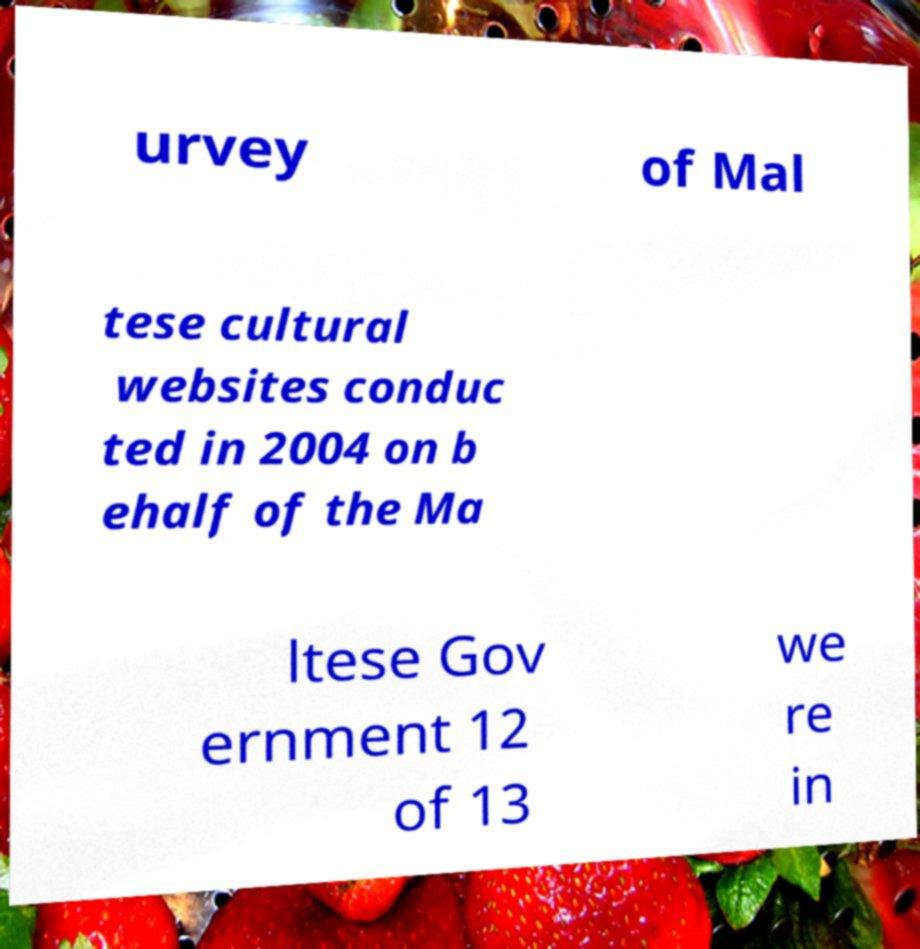Can you read and provide the text displayed in the image?This photo seems to have some interesting text. Can you extract and type it out for me? urvey of Mal tese cultural websites conduc ted in 2004 on b ehalf of the Ma ltese Gov ernment 12 of 13 we re in 